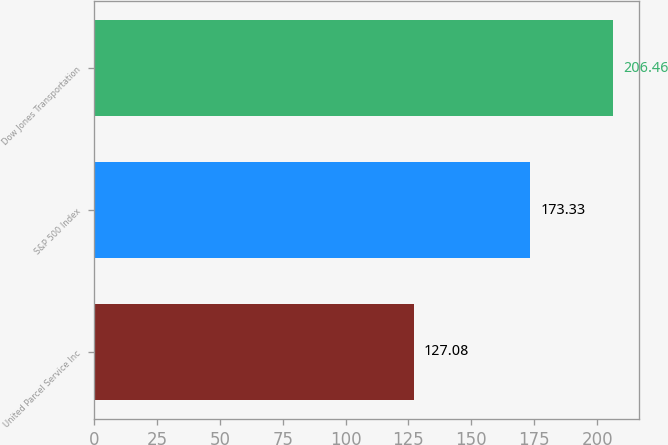<chart> <loc_0><loc_0><loc_500><loc_500><bar_chart><fcel>United Parcel Service Inc<fcel>S&P 500 Index<fcel>Dow Jones Transportation<nl><fcel>127.08<fcel>173.33<fcel>206.46<nl></chart> 